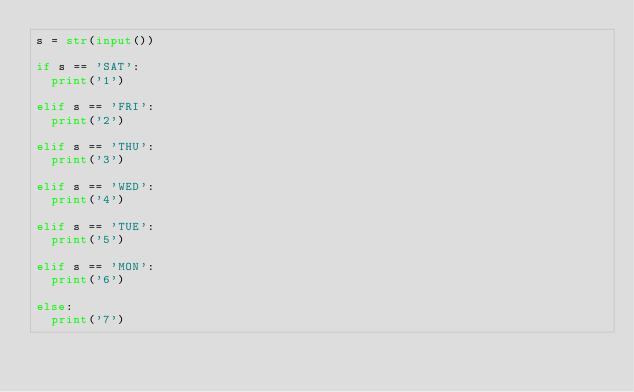Convert code to text. <code><loc_0><loc_0><loc_500><loc_500><_Python_>s = str(input())
  
if s == 'SAT':
  print('1')
  
elif s == 'FRI':
  print('2')
  
elif s == 'THU':
  print('3')
  
elif s == 'WED':
  print('4')

elif s == 'TUE':
  print('5')
  
elif s == 'MON':
  print('6')

else:
  print('7')
</code> 